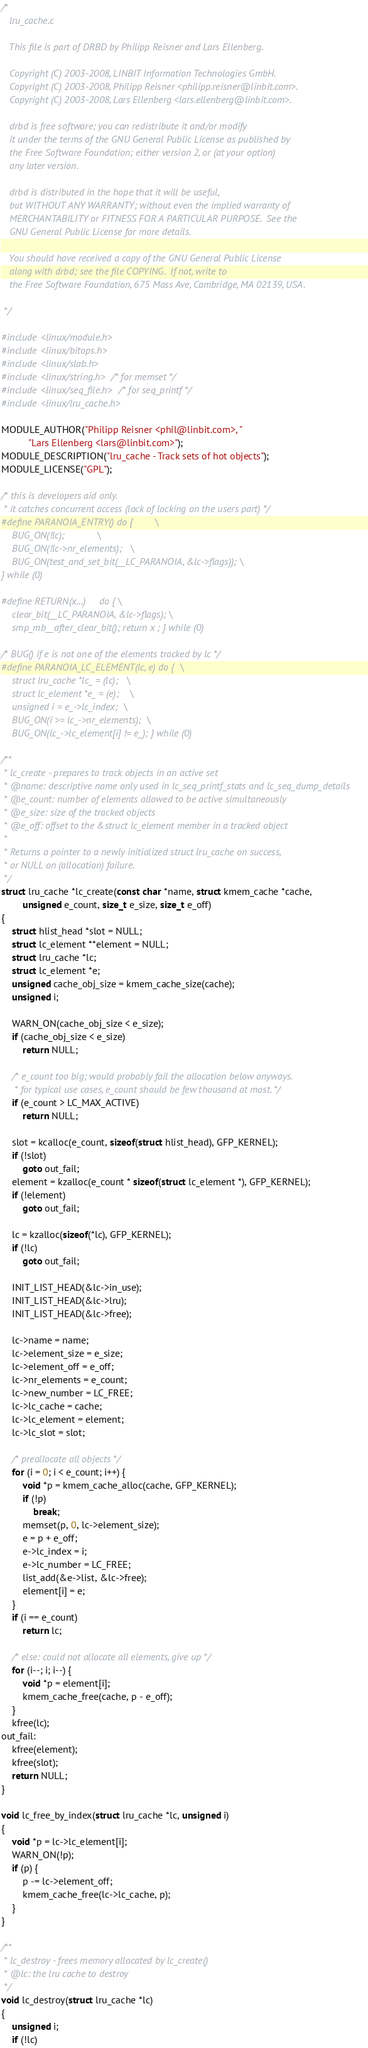Convert code to text. <code><loc_0><loc_0><loc_500><loc_500><_C_>/*
   lru_cache.c

   This file is part of DRBD by Philipp Reisner and Lars Ellenberg.

   Copyright (C) 2003-2008, LINBIT Information Technologies GmbH.
   Copyright (C) 2003-2008, Philipp Reisner <philipp.reisner@linbit.com>.
   Copyright (C) 2003-2008, Lars Ellenberg <lars.ellenberg@linbit.com>.

   drbd is free software; you can redistribute it and/or modify
   it under the terms of the GNU General Public License as published by
   the Free Software Foundation; either version 2, or (at your option)
   any later version.

   drbd is distributed in the hope that it will be useful,
   but WITHOUT ANY WARRANTY; without even the implied warranty of
   MERCHANTABILITY or FITNESS FOR A PARTICULAR PURPOSE.  See the
   GNU General Public License for more details.

   You should have received a copy of the GNU General Public License
   along with drbd; see the file COPYING.  If not, write to
   the Free Software Foundation, 675 Mass Ave, Cambridge, MA 02139, USA.

 */

#include <linux/module.h>
#include <linux/bitops.h>
#include <linux/slab.h>
#include <linux/string.h> /* for memset */
#include <linux/seq_file.h> /* for seq_printf */
#include <linux/lru_cache.h>

MODULE_AUTHOR("Philipp Reisner <phil@linbit.com>, "
	      "Lars Ellenberg <lars@linbit.com>");
MODULE_DESCRIPTION("lru_cache - Track sets of hot objects");
MODULE_LICENSE("GPL");

/* this is developers aid only.
 * it catches concurrent access (lack of locking on the users part) */
#define PARANOIA_ENTRY() do {		\
	BUG_ON(!lc);			\
	BUG_ON(!lc->nr_elements);	\
	BUG_ON(test_and_set_bit(__LC_PARANOIA, &lc->flags)); \
} while (0)

#define RETURN(x...)     do { \
	clear_bit(__LC_PARANOIA, &lc->flags); \
	smp_mb__after_clear_bit(); return x ; } while (0)

/* BUG() if e is not one of the elements tracked by lc */
#define PARANOIA_LC_ELEMENT(lc, e) do {	\
	struct lru_cache *lc_ = (lc);	\
	struct lc_element *e_ = (e);	\
	unsigned i = e_->lc_index;	\
	BUG_ON(i >= lc_->nr_elements);	\
	BUG_ON(lc_->lc_element[i] != e_); } while (0)

/**
 * lc_create - prepares to track objects in an active set
 * @name: descriptive name only used in lc_seq_printf_stats and lc_seq_dump_details
 * @e_count: number of elements allowed to be active simultaneously
 * @e_size: size of the tracked objects
 * @e_off: offset to the &struct lc_element member in a tracked object
 *
 * Returns a pointer to a newly initialized struct lru_cache on success,
 * or NULL on (allocation) failure.
 */
struct lru_cache *lc_create(const char *name, struct kmem_cache *cache,
		unsigned e_count, size_t e_size, size_t e_off)
{
	struct hlist_head *slot = NULL;
	struct lc_element **element = NULL;
	struct lru_cache *lc;
	struct lc_element *e;
	unsigned cache_obj_size = kmem_cache_size(cache);
	unsigned i;

	WARN_ON(cache_obj_size < e_size);
	if (cache_obj_size < e_size)
		return NULL;

	/* e_count too big; would probably fail the allocation below anyways.
	 * for typical use cases, e_count should be few thousand at most. */
	if (e_count > LC_MAX_ACTIVE)
		return NULL;

	slot = kcalloc(e_count, sizeof(struct hlist_head), GFP_KERNEL);
	if (!slot)
		goto out_fail;
	element = kzalloc(e_count * sizeof(struct lc_element *), GFP_KERNEL);
	if (!element)
		goto out_fail;

	lc = kzalloc(sizeof(*lc), GFP_KERNEL);
	if (!lc)
		goto out_fail;

	INIT_LIST_HEAD(&lc->in_use);
	INIT_LIST_HEAD(&lc->lru);
	INIT_LIST_HEAD(&lc->free);

	lc->name = name;
	lc->element_size = e_size;
	lc->element_off = e_off;
	lc->nr_elements = e_count;
	lc->new_number = LC_FREE;
	lc->lc_cache = cache;
	lc->lc_element = element;
	lc->lc_slot = slot;

	/* preallocate all objects */
	for (i = 0; i < e_count; i++) {
		void *p = kmem_cache_alloc(cache, GFP_KERNEL);
		if (!p)
			break;
		memset(p, 0, lc->element_size);
		e = p + e_off;
		e->lc_index = i;
		e->lc_number = LC_FREE;
		list_add(&e->list, &lc->free);
		element[i] = e;
	}
	if (i == e_count)
		return lc;

	/* else: could not allocate all elements, give up */
	for (i--; i; i--) {
		void *p = element[i];
		kmem_cache_free(cache, p - e_off);
	}
	kfree(lc);
out_fail:
	kfree(element);
	kfree(slot);
	return NULL;
}

void lc_free_by_index(struct lru_cache *lc, unsigned i)
{
	void *p = lc->lc_element[i];
	WARN_ON(!p);
	if (p) {
		p -= lc->element_off;
		kmem_cache_free(lc->lc_cache, p);
	}
}

/**
 * lc_destroy - frees memory allocated by lc_create()
 * @lc: the lru cache to destroy
 */
void lc_destroy(struct lru_cache *lc)
{
	unsigned i;
	if (!lc)</code> 